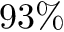<formula> <loc_0><loc_0><loc_500><loc_500>9 3 \%</formula> 